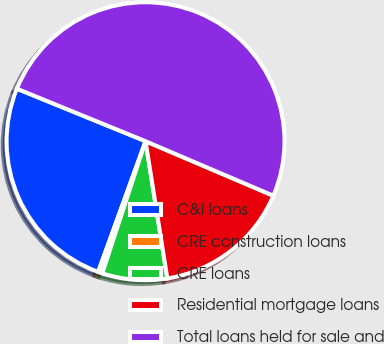Convert chart to OTSL. <chart><loc_0><loc_0><loc_500><loc_500><pie_chart><fcel>C&I loans<fcel>CRE construction loans<fcel>CRE loans<fcel>Residential mortgage loans<fcel>Total loans held for sale and<nl><fcel>25.63%<fcel>0.5%<fcel>7.54%<fcel>16.08%<fcel>50.25%<nl></chart> 